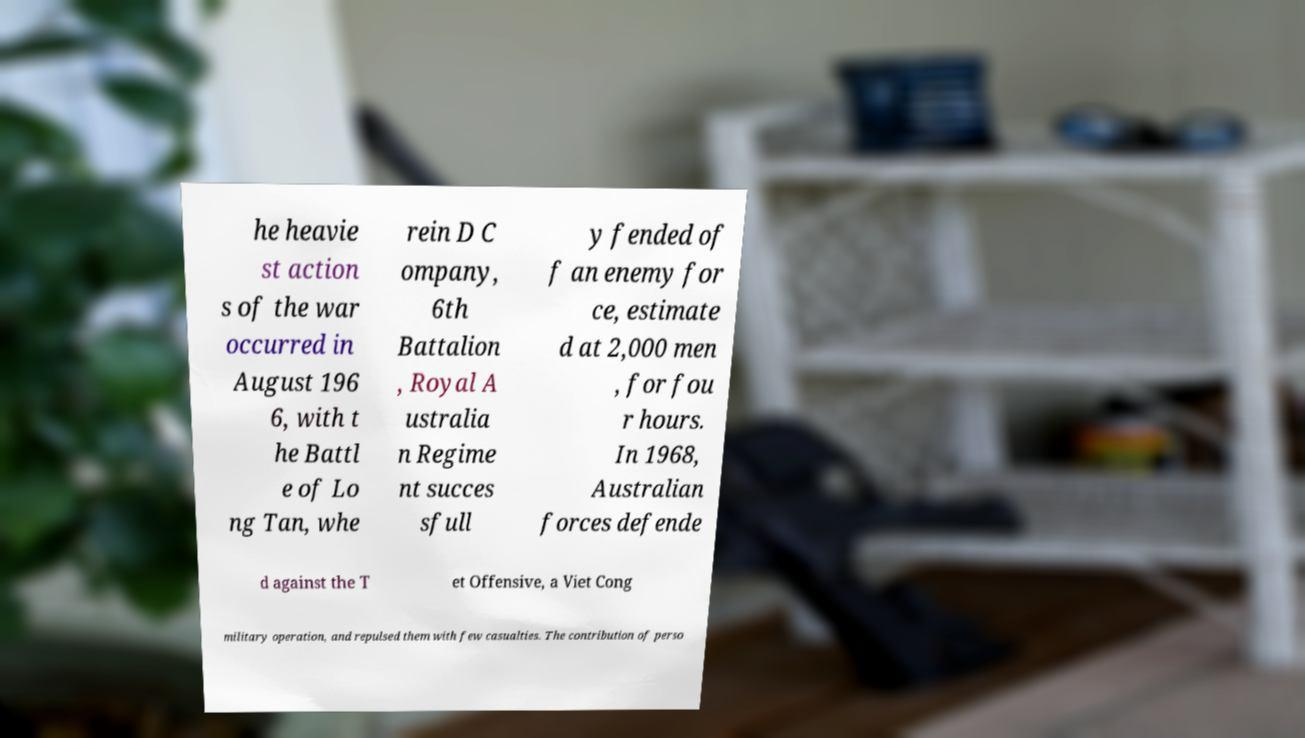Can you read and provide the text displayed in the image?This photo seems to have some interesting text. Can you extract and type it out for me? he heavie st action s of the war occurred in August 196 6, with t he Battl e of Lo ng Tan, whe rein D C ompany, 6th Battalion , Royal A ustralia n Regime nt succes sfull y fended of f an enemy for ce, estimate d at 2,000 men , for fou r hours. In 1968, Australian forces defende d against the T et Offensive, a Viet Cong military operation, and repulsed them with few casualties. The contribution of perso 